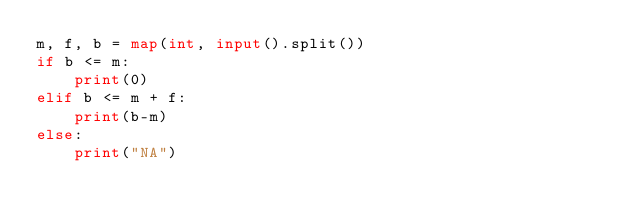Convert code to text. <code><loc_0><loc_0><loc_500><loc_500><_Python_>m, f, b = map(int, input().split())
if b <= m:
    print(0)
elif b <= m + f:
    print(b-m)
else:
    print("NA")
</code> 